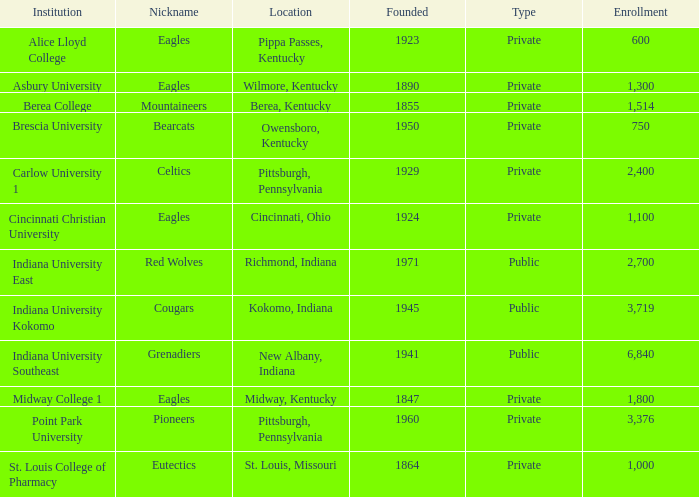Which among the private colleges is the eldest, and has the nickname mountaineers? 1855.0. Can you give me this table as a dict? {'header': ['Institution', 'Nickname', 'Location', 'Founded', 'Type', 'Enrollment'], 'rows': [['Alice Lloyd College', 'Eagles', 'Pippa Passes, Kentucky', '1923', 'Private', '600'], ['Asbury University', 'Eagles', 'Wilmore, Kentucky', '1890', 'Private', '1,300'], ['Berea College', 'Mountaineers', 'Berea, Kentucky', '1855', 'Private', '1,514'], ['Brescia University', 'Bearcats', 'Owensboro, Kentucky', '1950', 'Private', '750'], ['Carlow University 1', 'Celtics', 'Pittsburgh, Pennsylvania', '1929', 'Private', '2,400'], ['Cincinnati Christian University', 'Eagles', 'Cincinnati, Ohio', '1924', 'Private', '1,100'], ['Indiana University East', 'Red Wolves', 'Richmond, Indiana', '1971', 'Public', '2,700'], ['Indiana University Kokomo', 'Cougars', 'Kokomo, Indiana', '1945', 'Public', '3,719'], ['Indiana University Southeast', 'Grenadiers', 'New Albany, Indiana', '1941', 'Public', '6,840'], ['Midway College 1', 'Eagles', 'Midway, Kentucky', '1847', 'Private', '1,800'], ['Point Park University', 'Pioneers', 'Pittsburgh, Pennsylvania', '1960', 'Private', '3,376'], ['St. Louis College of Pharmacy', 'Eutectics', 'St. Louis, Missouri', '1864', 'Private', '1,000']]} 